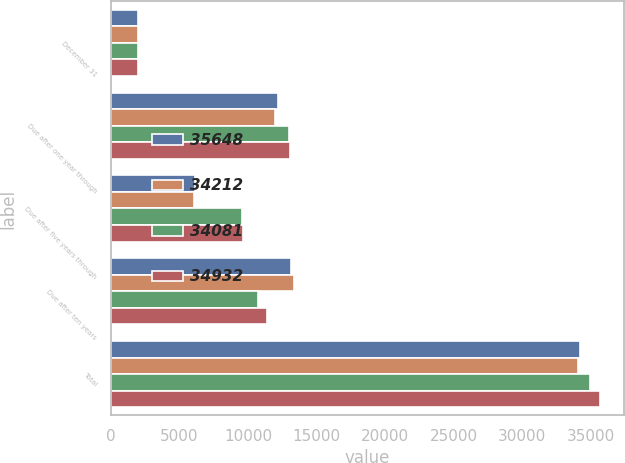Convert chart. <chart><loc_0><loc_0><loc_500><loc_500><stacked_bar_chart><ecel><fcel>December 31<fcel>Due after one year through<fcel>Due after five years through<fcel>Due after ten years<fcel>Total<nl><fcel>35648<fcel>2007<fcel>12219<fcel>6150<fcel>13158<fcel>34212<nl><fcel>34212<fcel>2007<fcel>12002<fcel>6052<fcel>13349<fcel>34081<nl><fcel>34081<fcel>2006<fcel>13023<fcel>9555<fcel>10755<fcel>34932<nl><fcel>34932<fcel>2006<fcel>13039<fcel>9619<fcel>11389<fcel>35648<nl></chart> 